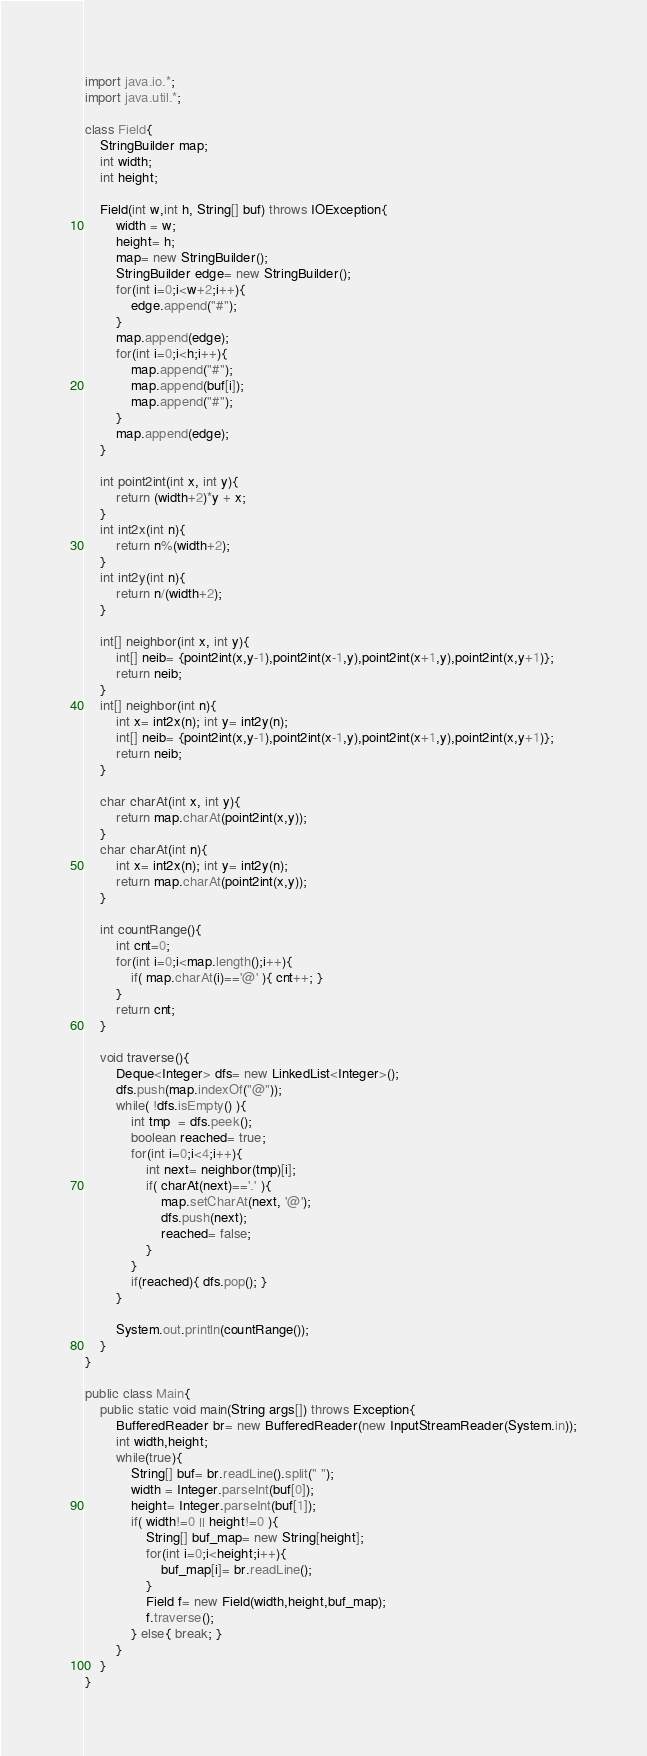Convert code to text. <code><loc_0><loc_0><loc_500><loc_500><_Java_>import java.io.*;
import java.util.*;

class Field{
	StringBuilder map;
	int width;
	int height;
	
	Field(int w,int h, String[] buf) throws IOException{
		width = w;
		height= h;
		map= new StringBuilder();
		StringBuilder edge= new StringBuilder();
		for(int i=0;i<w+2;i++){
			edge.append("#");
		}
		map.append(edge);
		for(int i=0;i<h;i++){
			map.append("#");
			map.append(buf[i]);
			map.append("#");
		}
		map.append(edge);
	}
	
	int point2int(int x, int y){
		return (width+2)*y + x;
	}
	int int2x(int n){
		return n%(width+2);
	}
	int int2y(int n){
		return n/(width+2);
	}
	
	int[] neighbor(int x, int y){
		int[] neib= {point2int(x,y-1),point2int(x-1,y),point2int(x+1,y),point2int(x,y+1)};
		return neib;
	}
	int[] neighbor(int n){
		int x= int2x(n); int y= int2y(n);
		int[] neib= {point2int(x,y-1),point2int(x-1,y),point2int(x+1,y),point2int(x,y+1)};
		return neib;
	}

	char charAt(int x, int y){
		return map.charAt(point2int(x,y));
	}
	char charAt(int n){
		int x= int2x(n); int y= int2y(n);
		return map.charAt(point2int(x,y));
	}
	
	int countRange(){
		int cnt=0;
		for(int i=0;i<map.length();i++){
			if( map.charAt(i)=='@' ){ cnt++; }
		}
		return cnt;
	}
	
	void traverse(){
		Deque<Integer> dfs= new LinkedList<Integer>();
		dfs.push(map.indexOf("@"));
		while( !dfs.isEmpty() ){
			int tmp  = dfs.peek();
			boolean reached= true;
			for(int i=0;i<4;i++){
				int next= neighbor(tmp)[i];
				if( charAt(next)=='.' ){
					map.setCharAt(next, '@');
					dfs.push(next);
					reached= false;
				}
			}
			if(reached){ dfs.pop(); }
		}

		System.out.println(countRange());
	}
}

public class Main{
    public static void main(String args[]) throws Exception{
    	BufferedReader br= new BufferedReader(new InputStreamReader(System.in));
    	int width,height;
    	while(true){
    		String[] buf= br.readLine().split(" ");
    		width = Integer.parseInt(buf[0]);
    		height= Integer.parseInt(buf[1]);
    		if( width!=0 || height!=0 ){
    			String[] buf_map= new String[height];
    			for(int i=0;i<height;i++){
    				buf_map[i]= br.readLine();
    			}
    			Field f= new Field(width,height,buf_map); 
    			f.traverse();
    		} else{ break; }
    	}
    }
}</code> 